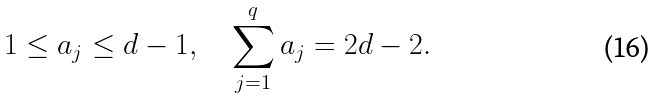Convert formula to latex. <formula><loc_0><loc_0><loc_500><loc_500>1 \leq a _ { j } \leq d - 1 , \quad \sum _ { j = 1 } ^ { q } a _ { j } = 2 d - 2 .</formula> 